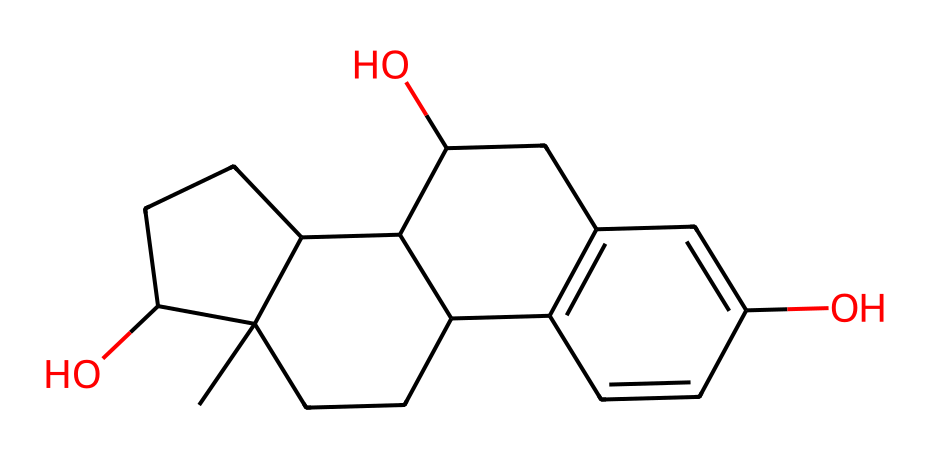how many carbon atoms are present in this structure? The SMILES notation indicates each carbon is represented by "C." By counting the number of "C" in the SMILES, there are 18 carbon atoms in total.
Answer: 18 how many hydroxyl (–OH) groups does this compound contain? In the chemical structure derived from the SMILES representation, the hydroxyl groups are indicated by the "O" connected to hydrogen atoms. There are two "O" atoms that have bonds in the structure, each associated with a hydrogen indicating two hydroxyl groups.
Answer: 2 what type of compound is indicated by this SMILES? The presence of multiple aromatic rings in the chemical structure suggests it is a polycyclic aromatic compound. This is characterized by fused benzene rings.
Answer: polycyclic aromatic compound how many rings are present in this chemical structure? Examining the structure formed by the SMILES notation shows that the compound contains a total of four interconnected rings. This can be counted by identifying the cyclic parts indicated by the numbers in the SMILES notation that signify the start and end of each ring.
Answer: 4 which functional group is prevalent in this compound? The presence of –OH groups indicates that this compound has significant alcohol functionality. Specifically, the hydroxyl groups impact the chemical properties, highlighting that this compound is a type of phenolic compound.
Answer: alcohol what is the molecular formula for this chemical compound? To determine the molecular formula, we count the number of each type of atom present in the SMILES. This compound has 18 carbon atoms, 20 hydrogen atoms, and 2 oxygen atoms, leading to the molecular formula C18H20O2.
Answer: C18H20O2 